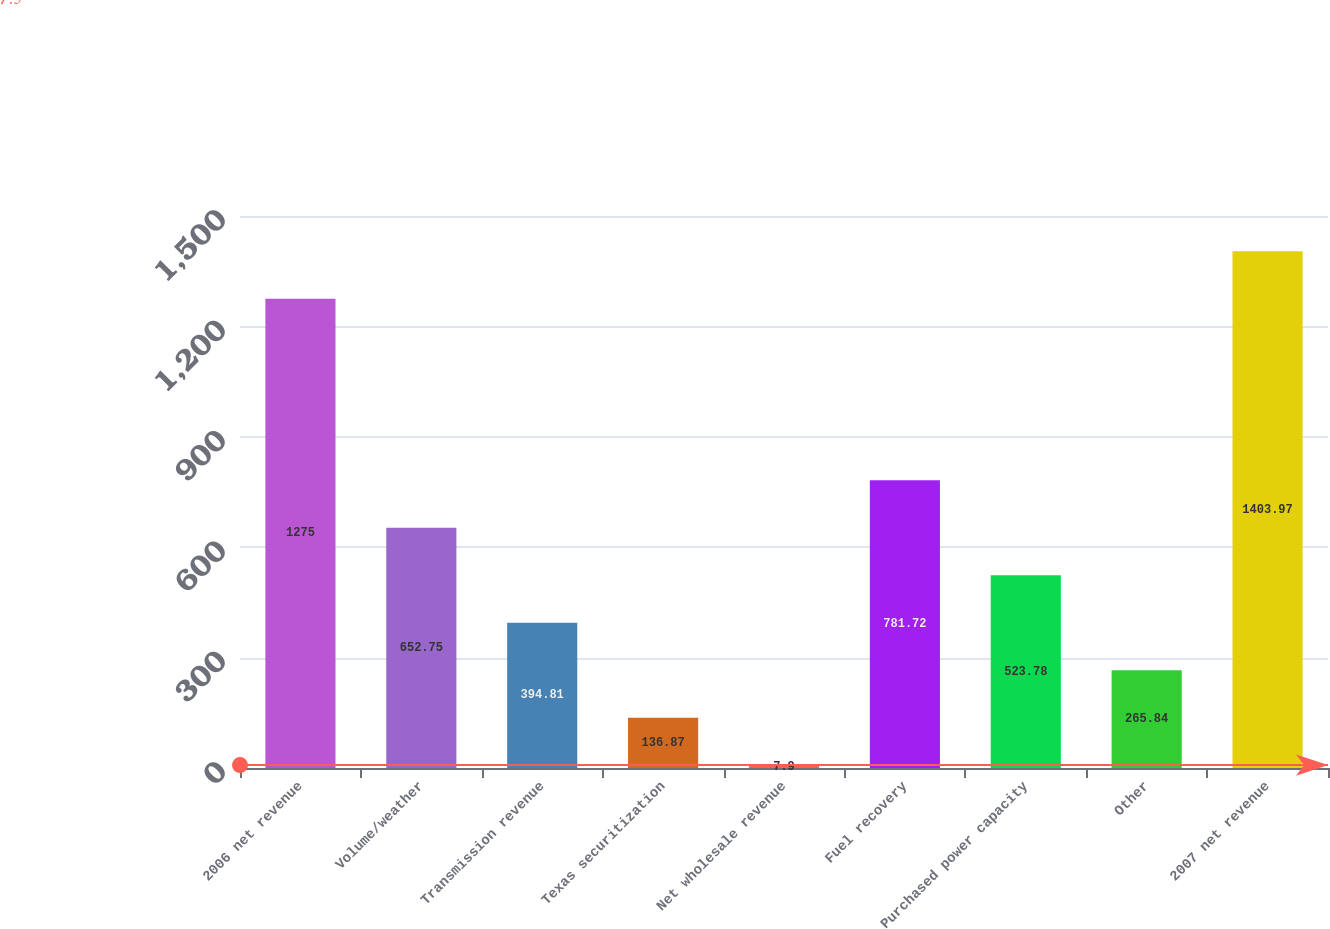Convert chart to OTSL. <chart><loc_0><loc_0><loc_500><loc_500><bar_chart><fcel>2006 net revenue<fcel>Volume/weather<fcel>Transmission revenue<fcel>Texas securitization<fcel>Net wholesale revenue<fcel>Fuel recovery<fcel>Purchased power capacity<fcel>Other<fcel>2007 net revenue<nl><fcel>1275<fcel>652.75<fcel>394.81<fcel>136.87<fcel>7.9<fcel>781.72<fcel>523.78<fcel>265.84<fcel>1403.97<nl></chart> 